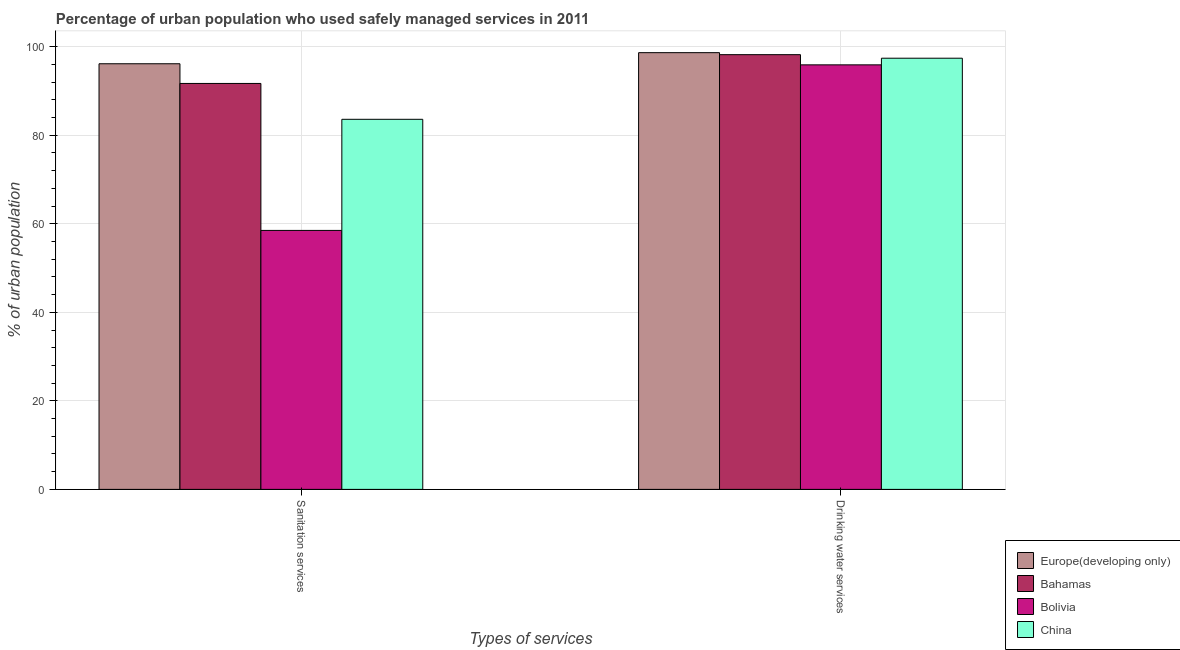Are the number of bars per tick equal to the number of legend labels?
Your answer should be very brief. Yes. Are the number of bars on each tick of the X-axis equal?
Keep it short and to the point. Yes. How many bars are there on the 1st tick from the right?
Provide a short and direct response. 4. What is the label of the 1st group of bars from the left?
Give a very brief answer. Sanitation services. What is the percentage of urban population who used sanitation services in Bolivia?
Make the answer very short. 58.5. Across all countries, what is the maximum percentage of urban population who used sanitation services?
Give a very brief answer. 96.15. Across all countries, what is the minimum percentage of urban population who used sanitation services?
Keep it short and to the point. 58.5. In which country was the percentage of urban population who used drinking water services maximum?
Provide a short and direct response. Europe(developing only). In which country was the percentage of urban population who used sanitation services minimum?
Offer a terse response. Bolivia. What is the total percentage of urban population who used drinking water services in the graph?
Provide a short and direct response. 390.15. What is the difference between the percentage of urban population who used sanitation services in Bolivia and that in Bahamas?
Your response must be concise. -33.2. What is the difference between the percentage of urban population who used drinking water services in Bahamas and the percentage of urban population who used sanitation services in Europe(developing only)?
Provide a succinct answer. 2.05. What is the average percentage of urban population who used sanitation services per country?
Your answer should be compact. 82.49. What is the difference between the percentage of urban population who used sanitation services and percentage of urban population who used drinking water services in Bahamas?
Make the answer very short. -6.5. What is the ratio of the percentage of urban population who used drinking water services in Bolivia to that in China?
Keep it short and to the point. 0.98. Is the percentage of urban population who used drinking water services in Bahamas less than that in Bolivia?
Provide a short and direct response. No. In how many countries, is the percentage of urban population who used drinking water services greater than the average percentage of urban population who used drinking water services taken over all countries?
Give a very brief answer. 2. What does the 1st bar from the right in Sanitation services represents?
Provide a short and direct response. China. How many bars are there?
Offer a terse response. 8. What is the difference between two consecutive major ticks on the Y-axis?
Your response must be concise. 20. Are the values on the major ticks of Y-axis written in scientific E-notation?
Your answer should be compact. No. Does the graph contain any zero values?
Your answer should be compact. No. Does the graph contain grids?
Give a very brief answer. Yes. Where does the legend appear in the graph?
Make the answer very short. Bottom right. How are the legend labels stacked?
Make the answer very short. Vertical. What is the title of the graph?
Ensure brevity in your answer.  Percentage of urban population who used safely managed services in 2011. What is the label or title of the X-axis?
Ensure brevity in your answer.  Types of services. What is the label or title of the Y-axis?
Make the answer very short. % of urban population. What is the % of urban population in Europe(developing only) in Sanitation services?
Offer a terse response. 96.15. What is the % of urban population of Bahamas in Sanitation services?
Give a very brief answer. 91.7. What is the % of urban population of Bolivia in Sanitation services?
Provide a succinct answer. 58.5. What is the % of urban population of China in Sanitation services?
Make the answer very short. 83.6. What is the % of urban population in Europe(developing only) in Drinking water services?
Keep it short and to the point. 98.65. What is the % of urban population of Bahamas in Drinking water services?
Ensure brevity in your answer.  98.2. What is the % of urban population of Bolivia in Drinking water services?
Offer a very short reply. 95.9. What is the % of urban population of China in Drinking water services?
Keep it short and to the point. 97.4. Across all Types of services, what is the maximum % of urban population in Europe(developing only)?
Offer a terse response. 98.65. Across all Types of services, what is the maximum % of urban population of Bahamas?
Your answer should be compact. 98.2. Across all Types of services, what is the maximum % of urban population in Bolivia?
Keep it short and to the point. 95.9. Across all Types of services, what is the maximum % of urban population of China?
Your answer should be very brief. 97.4. Across all Types of services, what is the minimum % of urban population of Europe(developing only)?
Your answer should be very brief. 96.15. Across all Types of services, what is the minimum % of urban population of Bahamas?
Provide a short and direct response. 91.7. Across all Types of services, what is the minimum % of urban population of Bolivia?
Keep it short and to the point. 58.5. Across all Types of services, what is the minimum % of urban population of China?
Make the answer very short. 83.6. What is the total % of urban population in Europe(developing only) in the graph?
Your response must be concise. 194.8. What is the total % of urban population in Bahamas in the graph?
Give a very brief answer. 189.9. What is the total % of urban population of Bolivia in the graph?
Provide a succinct answer. 154.4. What is the total % of urban population of China in the graph?
Offer a very short reply. 181. What is the difference between the % of urban population of Europe(developing only) in Sanitation services and that in Drinking water services?
Your answer should be compact. -2.51. What is the difference between the % of urban population in Bolivia in Sanitation services and that in Drinking water services?
Keep it short and to the point. -37.4. What is the difference between the % of urban population in Europe(developing only) in Sanitation services and the % of urban population in Bahamas in Drinking water services?
Provide a succinct answer. -2.05. What is the difference between the % of urban population in Europe(developing only) in Sanitation services and the % of urban population in Bolivia in Drinking water services?
Ensure brevity in your answer.  0.25. What is the difference between the % of urban population in Europe(developing only) in Sanitation services and the % of urban population in China in Drinking water services?
Offer a terse response. -1.25. What is the difference between the % of urban population in Bahamas in Sanitation services and the % of urban population in China in Drinking water services?
Your response must be concise. -5.7. What is the difference between the % of urban population of Bolivia in Sanitation services and the % of urban population of China in Drinking water services?
Keep it short and to the point. -38.9. What is the average % of urban population of Europe(developing only) per Types of services?
Provide a short and direct response. 97.4. What is the average % of urban population in Bahamas per Types of services?
Offer a very short reply. 94.95. What is the average % of urban population of Bolivia per Types of services?
Give a very brief answer. 77.2. What is the average % of urban population of China per Types of services?
Provide a short and direct response. 90.5. What is the difference between the % of urban population of Europe(developing only) and % of urban population of Bahamas in Sanitation services?
Your answer should be compact. 4.45. What is the difference between the % of urban population of Europe(developing only) and % of urban population of Bolivia in Sanitation services?
Provide a short and direct response. 37.65. What is the difference between the % of urban population in Europe(developing only) and % of urban population in China in Sanitation services?
Your answer should be very brief. 12.55. What is the difference between the % of urban population in Bahamas and % of urban population in Bolivia in Sanitation services?
Offer a terse response. 33.2. What is the difference between the % of urban population of Bahamas and % of urban population of China in Sanitation services?
Offer a very short reply. 8.1. What is the difference between the % of urban population of Bolivia and % of urban population of China in Sanitation services?
Offer a very short reply. -25.1. What is the difference between the % of urban population of Europe(developing only) and % of urban population of Bahamas in Drinking water services?
Make the answer very short. 0.45. What is the difference between the % of urban population of Europe(developing only) and % of urban population of Bolivia in Drinking water services?
Your response must be concise. 2.75. What is the difference between the % of urban population in Europe(developing only) and % of urban population in China in Drinking water services?
Your answer should be very brief. 1.25. What is the ratio of the % of urban population in Europe(developing only) in Sanitation services to that in Drinking water services?
Your response must be concise. 0.97. What is the ratio of the % of urban population of Bahamas in Sanitation services to that in Drinking water services?
Keep it short and to the point. 0.93. What is the ratio of the % of urban population in Bolivia in Sanitation services to that in Drinking water services?
Provide a short and direct response. 0.61. What is the ratio of the % of urban population of China in Sanitation services to that in Drinking water services?
Make the answer very short. 0.86. What is the difference between the highest and the second highest % of urban population in Europe(developing only)?
Your answer should be compact. 2.51. What is the difference between the highest and the second highest % of urban population of Bahamas?
Your answer should be compact. 6.5. What is the difference between the highest and the second highest % of urban population in Bolivia?
Ensure brevity in your answer.  37.4. What is the difference between the highest and the lowest % of urban population of Europe(developing only)?
Your answer should be very brief. 2.51. What is the difference between the highest and the lowest % of urban population of Bahamas?
Give a very brief answer. 6.5. What is the difference between the highest and the lowest % of urban population of Bolivia?
Your answer should be compact. 37.4. What is the difference between the highest and the lowest % of urban population of China?
Your answer should be compact. 13.8. 